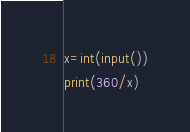<code> <loc_0><loc_0><loc_500><loc_500><_Python_>x=int(input())
print(360/x)</code> 